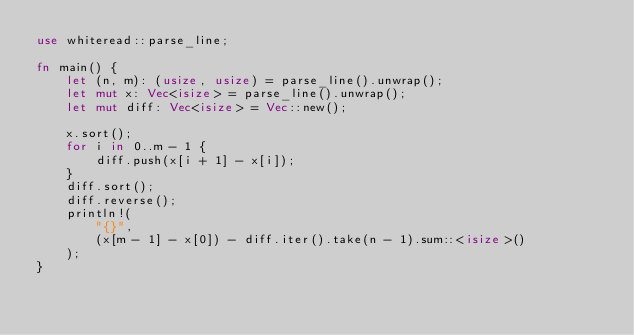Convert code to text. <code><loc_0><loc_0><loc_500><loc_500><_Rust_>use whiteread::parse_line;

fn main() {
    let (n, m): (usize, usize) = parse_line().unwrap();
    let mut x: Vec<isize> = parse_line().unwrap();
    let mut diff: Vec<isize> = Vec::new();

    x.sort();
    for i in 0..m - 1 {
        diff.push(x[i + 1] - x[i]);
    }
    diff.sort();
    diff.reverse();
    println!(
        "{}",
        (x[m - 1] - x[0]) - diff.iter().take(n - 1).sum::<isize>()
    );
}
</code> 